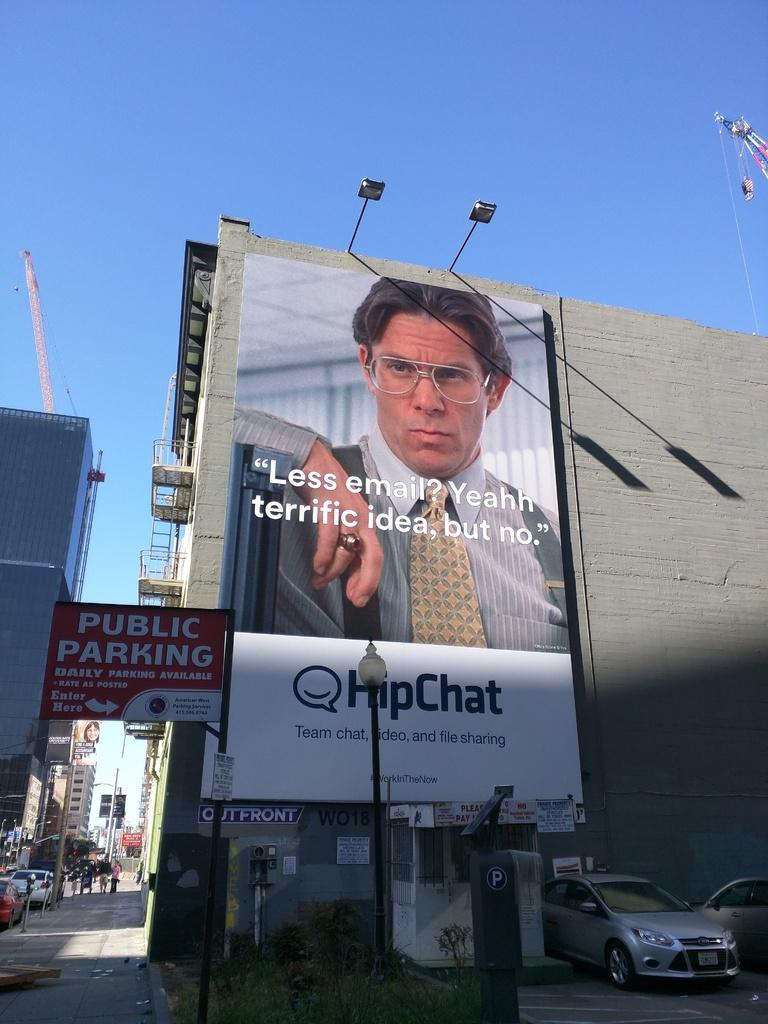<image>
Relay a brief, clear account of the picture shown. a large advertisement for hipchat featuring a character from a television show. 